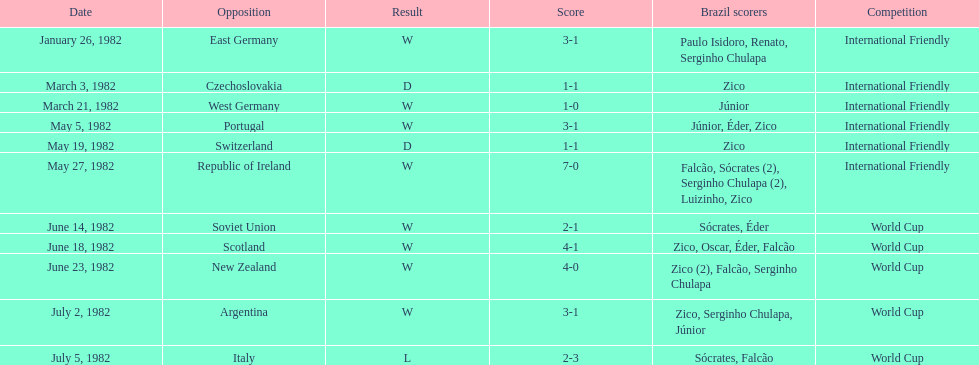What is the sum of all the losses brazil faced? 1. 